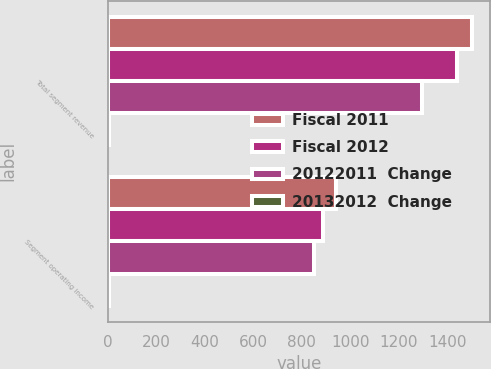Convert chart. <chart><loc_0><loc_0><loc_500><loc_500><stacked_bar_chart><ecel><fcel>Total segment revenue<fcel>Segment operating income<nl><fcel>Fiscal 2011<fcel>1503<fcel>942<nl><fcel>Fiscal 2012<fcel>1441<fcel>886<nl><fcel>20122011  Change<fcel>1298<fcel>850<nl><fcel>20132012  Change<fcel>4<fcel>6<nl></chart> 